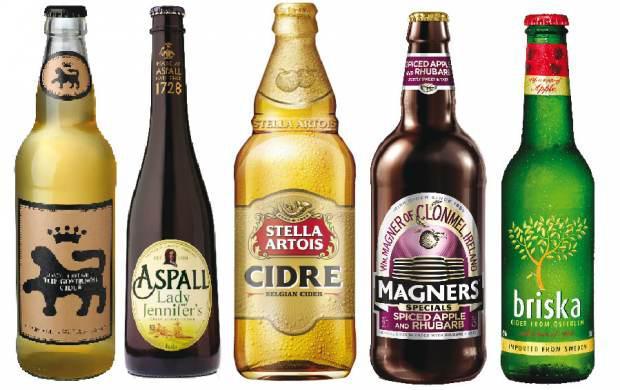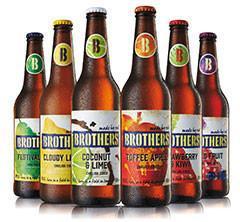The first image is the image on the left, the second image is the image on the right. Considering the images on both sides, is "The right and left images contain the same number of bottles." valid? Answer yes or no. No. The first image is the image on the left, the second image is the image on the right. Analyze the images presented: Is the assertion "Each image contains the same number of capped bottles, all with different labels." valid? Answer yes or no. No. 